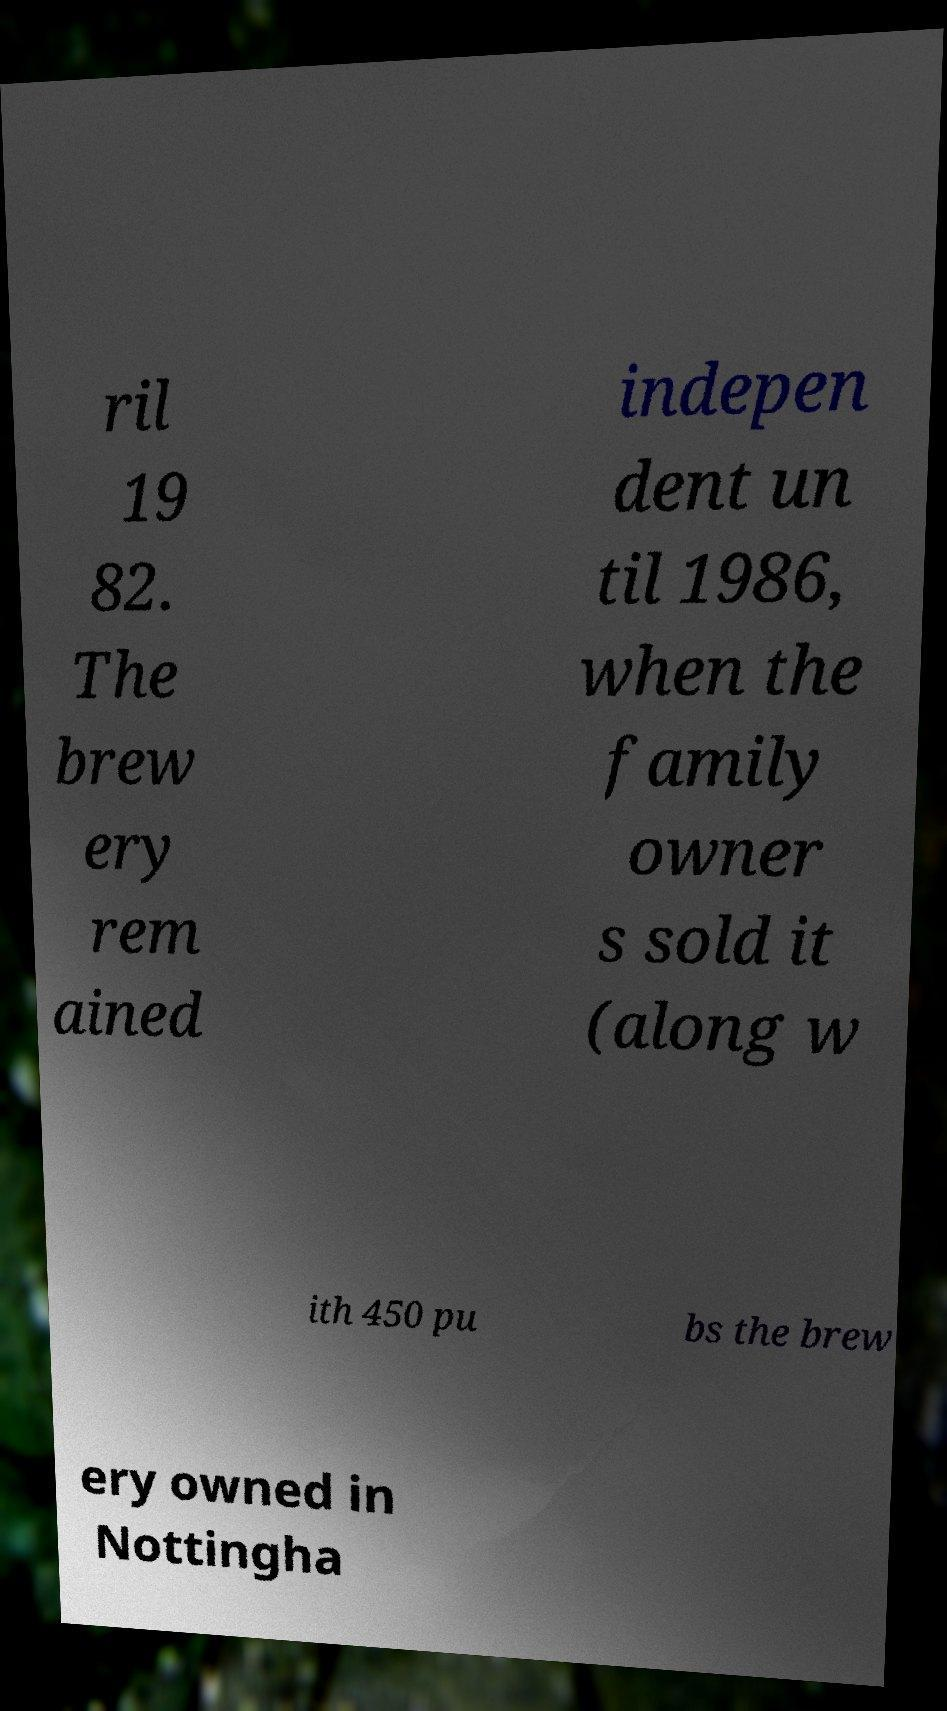I need the written content from this picture converted into text. Can you do that? ril 19 82. The brew ery rem ained indepen dent un til 1986, when the family owner s sold it (along w ith 450 pu bs the brew ery owned in Nottingha 